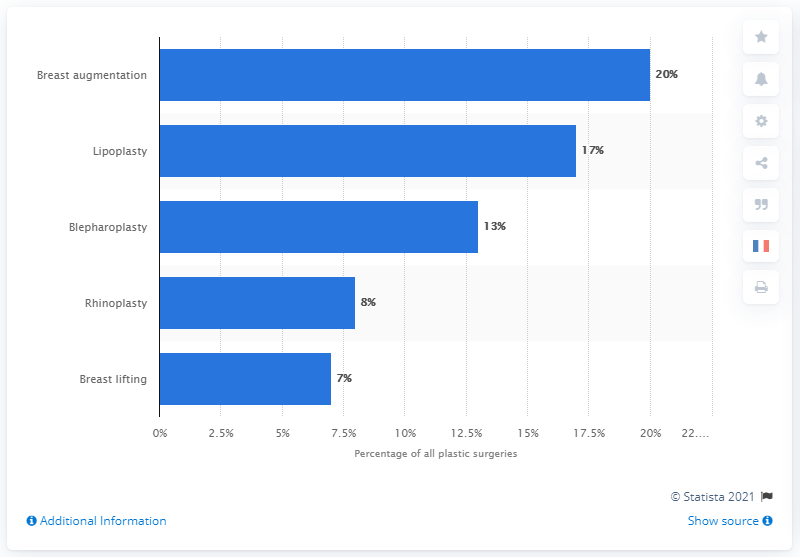Mention a couple of crucial points in this snapshot. Lipoplasty is the most common plastic surgery in France. 